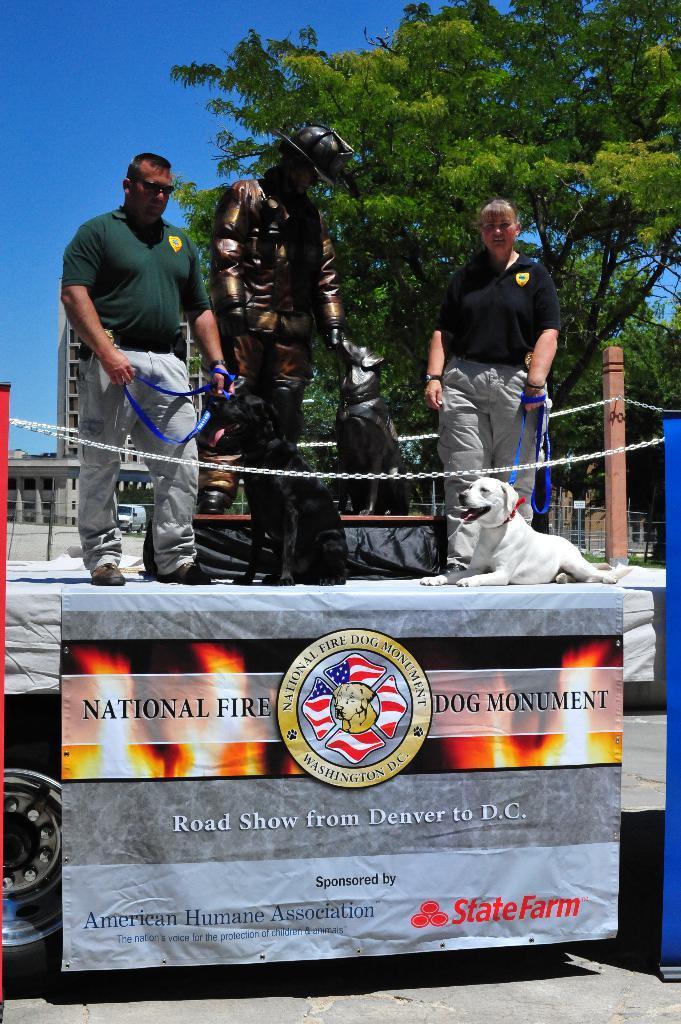Can you describe this image briefly? In this image, There are two persons wearing clothes and standing on the vehicle. These two persons are holding dogs with a leash. There is a tree behind this person. There is a statue at the center of this image. There is a sky in the top left of the image. 